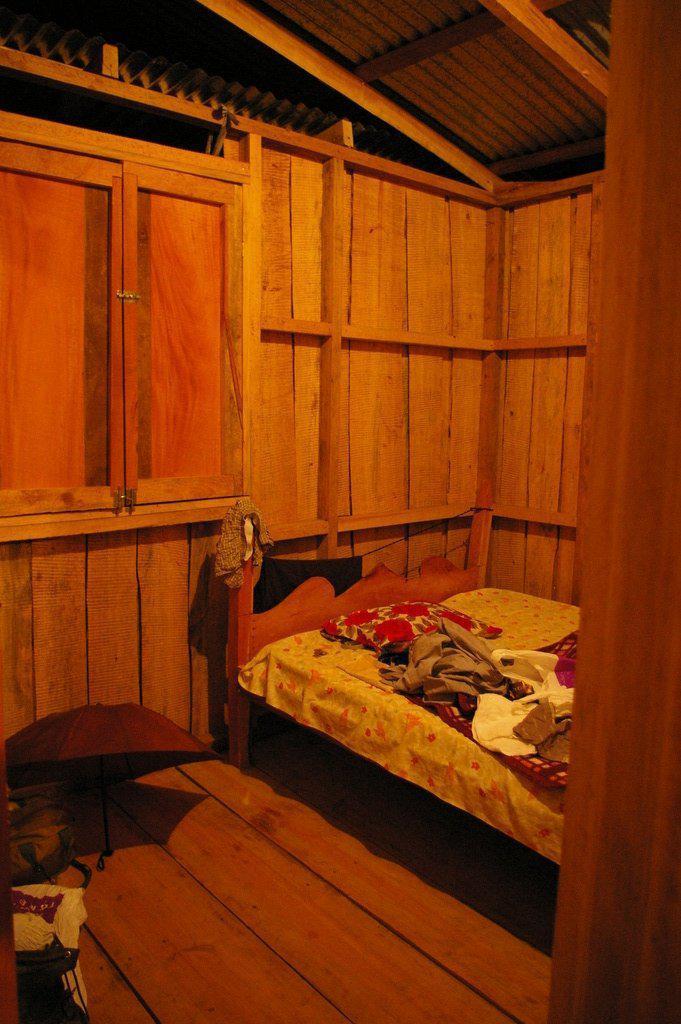In one or two sentences, can you explain what this image depicts? In this image there is a bed in the middle on which there are blankets and pillows. It looks like a wooden house. On the floor there is an umbrella and bags beside it. In the middle there is a wooden window. 